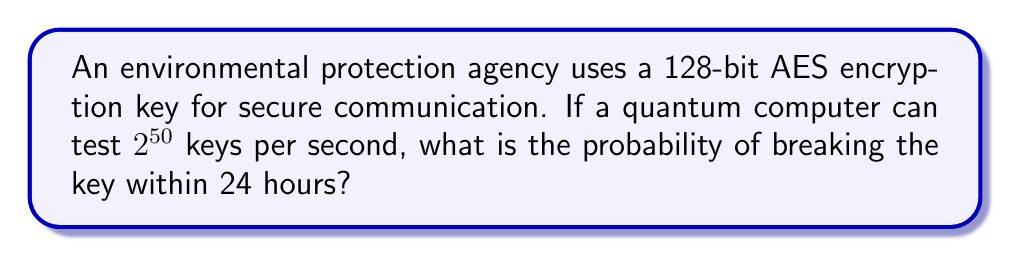Help me with this question. Let's approach this step-by-step:

1) First, we need to calculate the total number of possible 128-bit keys:
   $N = 2^{128}$

2) Next, we calculate how many keys the quantum computer can test in 24 hours:
   Keys tested per second = $2^{50}$
   Seconds in 24 hours = 24 * 60 * 60 = 86,400
   Keys tested in 24 hours = $2^{50} * 86,400 = 2^{50} * 2^{16.4} \approx 2^{66.4}$

3) The probability of success is the number of keys tested divided by the total number of possible keys:

   $P(\text{success}) = \frac{\text{Keys tested}}{\text{Total keys}} = \frac{2^{66.4}}{2^{128}} = 2^{66.4 - 128} = 2^{-61.6}$

4) To convert this to a decimal:
   $2^{-61.6} \approx 3.47 * 10^{-19}$

This extremely small probability indicates that it's virtually impossible to break the key within 24 hours, even with a powerful quantum computer.
Answer: $3.47 * 10^{-19}$ 